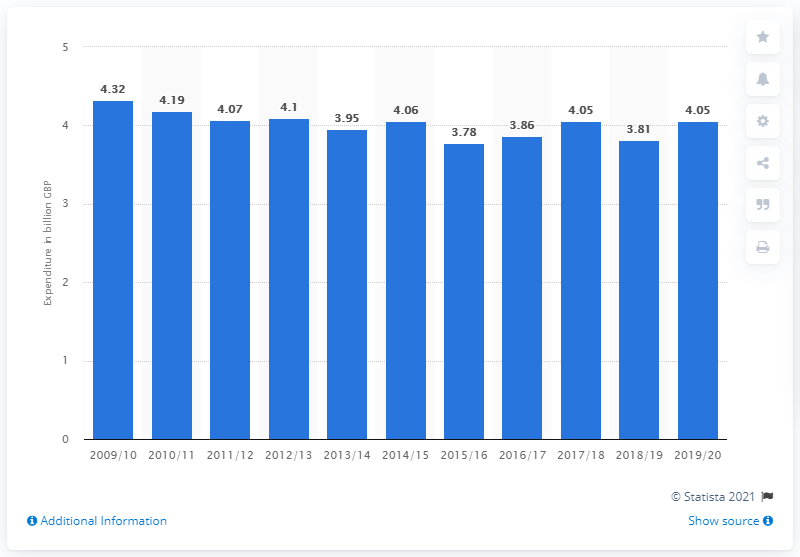List a handful of essential elements in this visual. In the previous year, the UK spent 3.81 billion pounds on cultural services. In 2019/20, the UK spent 4.05 on cultural services. 